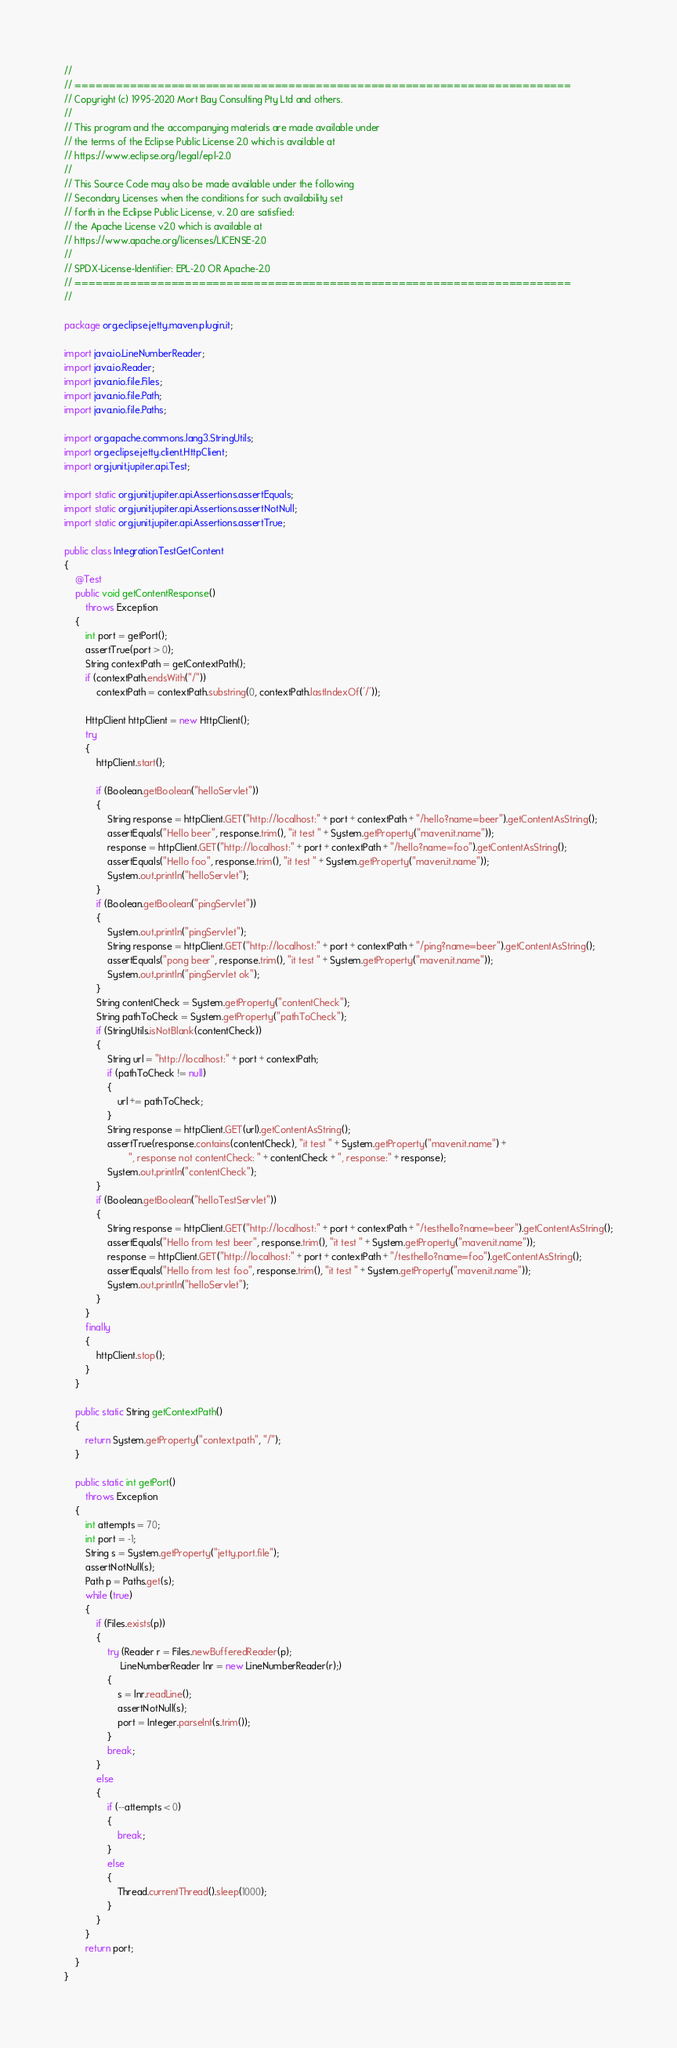<code> <loc_0><loc_0><loc_500><loc_500><_Java_>//
// ========================================================================
// Copyright (c) 1995-2020 Mort Bay Consulting Pty Ltd and others.
//
// This program and the accompanying materials are made available under
// the terms of the Eclipse Public License 2.0 which is available at
// https://www.eclipse.org/legal/epl-2.0
//
// This Source Code may also be made available under the following
// Secondary Licenses when the conditions for such availability set
// forth in the Eclipse Public License, v. 2.0 are satisfied:
// the Apache License v2.0 which is available at
// https://www.apache.org/licenses/LICENSE-2.0
//
// SPDX-License-Identifier: EPL-2.0 OR Apache-2.0
// ========================================================================
//

package org.eclipse.jetty.maven.plugin.it;

import java.io.LineNumberReader;
import java.io.Reader;
import java.nio.file.Files;
import java.nio.file.Path;
import java.nio.file.Paths;

import org.apache.commons.lang3.StringUtils;
import org.eclipse.jetty.client.HttpClient;
import org.junit.jupiter.api.Test;

import static org.junit.jupiter.api.Assertions.assertEquals;
import static org.junit.jupiter.api.Assertions.assertNotNull;
import static org.junit.jupiter.api.Assertions.assertTrue;

public class IntegrationTestGetContent
{
    @Test
    public void getContentResponse()
        throws Exception
    {
        int port = getPort();
        assertTrue(port > 0);
        String contextPath = getContextPath();
        if (contextPath.endsWith("/"))
            contextPath = contextPath.substring(0, contextPath.lastIndexOf('/'));

        HttpClient httpClient = new HttpClient();
        try
        {
            httpClient.start();

            if (Boolean.getBoolean("helloServlet"))
            {
                String response = httpClient.GET("http://localhost:" + port + contextPath + "/hello?name=beer").getContentAsString();
                assertEquals("Hello beer", response.trim(), "it test " + System.getProperty("maven.it.name"));
                response = httpClient.GET("http://localhost:" + port + contextPath + "/hello?name=foo").getContentAsString();
                assertEquals("Hello foo", response.trim(), "it test " + System.getProperty("maven.it.name"));
                System.out.println("helloServlet");
            }
            if (Boolean.getBoolean("pingServlet"))
            {
                System.out.println("pingServlet");
                String response = httpClient.GET("http://localhost:" + port + contextPath + "/ping?name=beer").getContentAsString();
                assertEquals("pong beer", response.trim(), "it test " + System.getProperty("maven.it.name"));
                System.out.println("pingServlet ok");
            }
            String contentCheck = System.getProperty("contentCheck");
            String pathToCheck = System.getProperty("pathToCheck");
            if (StringUtils.isNotBlank(contentCheck))
            {
                String url = "http://localhost:" + port + contextPath;
                if (pathToCheck != null)
                {
                    url += pathToCheck;
                }
                String response = httpClient.GET(url).getContentAsString();
                assertTrue(response.contains(contentCheck), "it test " + System.getProperty("maven.it.name") +
                        ", response not contentCheck: " + contentCheck + ", response:" + response);
                System.out.println("contentCheck");
            }
            if (Boolean.getBoolean("helloTestServlet"))
            {
                String response = httpClient.GET("http://localhost:" + port + contextPath + "/testhello?name=beer").getContentAsString();
                assertEquals("Hello from test beer", response.trim(), "it test " + System.getProperty("maven.it.name"));
                response = httpClient.GET("http://localhost:" + port + contextPath + "/testhello?name=foo").getContentAsString();
                assertEquals("Hello from test foo", response.trim(), "it test " + System.getProperty("maven.it.name"));
                System.out.println("helloServlet");
            }
        }
        finally
        {
            httpClient.stop();
        }
    }

    public static String getContextPath()
    {
        return System.getProperty("context.path", "/");
    }

    public static int getPort()
        throws Exception
    {
        int attempts = 70;
        int port = -1;
        String s = System.getProperty("jetty.port.file");
        assertNotNull(s);
        Path p = Paths.get(s);
        while (true)
        {
            if (Files.exists(p))
            {
                try (Reader r = Files.newBufferedReader(p);
                     LineNumberReader lnr = new LineNumberReader(r);)
                {
                    s = lnr.readLine();
                    assertNotNull(s);
                    port = Integer.parseInt(s.trim());
                }
                break;
            }
            else
            {
                if (--attempts < 0)
                {
                    break;
                }
                else
                {
                    Thread.currentThread().sleep(1000);
                }
            }
        }
        return port;
    }
}
</code> 